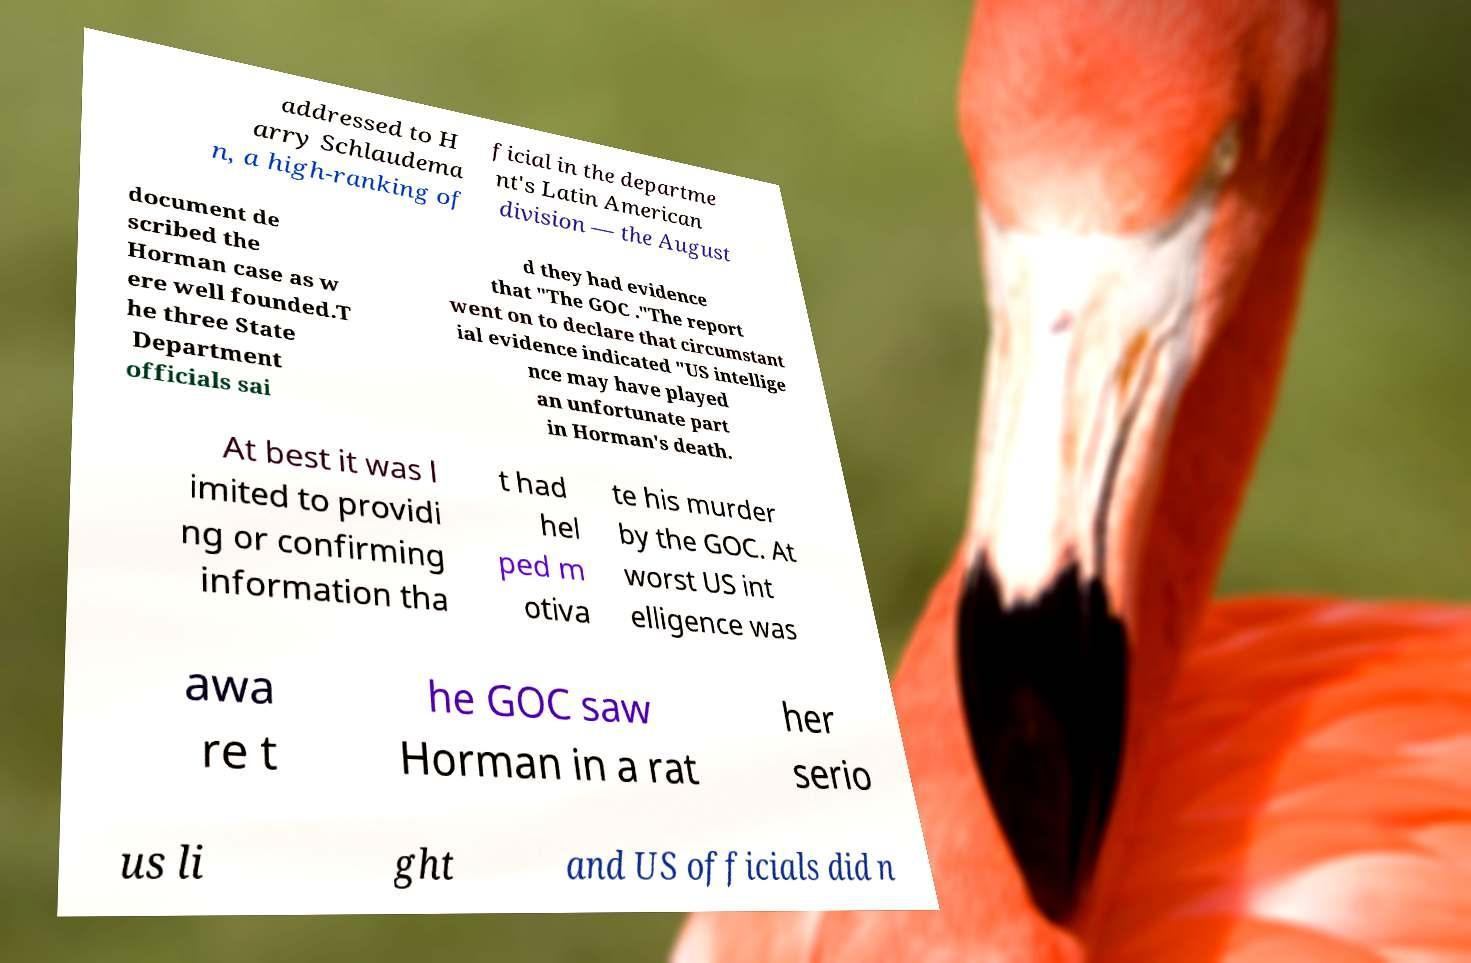Please identify and transcribe the text found in this image. addressed to H arry Schlaudema n, a high-ranking of ficial in the departme nt's Latin American division — the August document de scribed the Horman case as w ere well founded.T he three State Department officials sai d they had evidence that "The GOC ."The report went on to declare that circumstant ial evidence indicated "US intellige nce may have played an unfortunate part in Horman's death. At best it was l imited to providi ng or confirming information tha t had hel ped m otiva te his murder by the GOC. At worst US int elligence was awa re t he GOC saw Horman in a rat her serio us li ght and US officials did n 